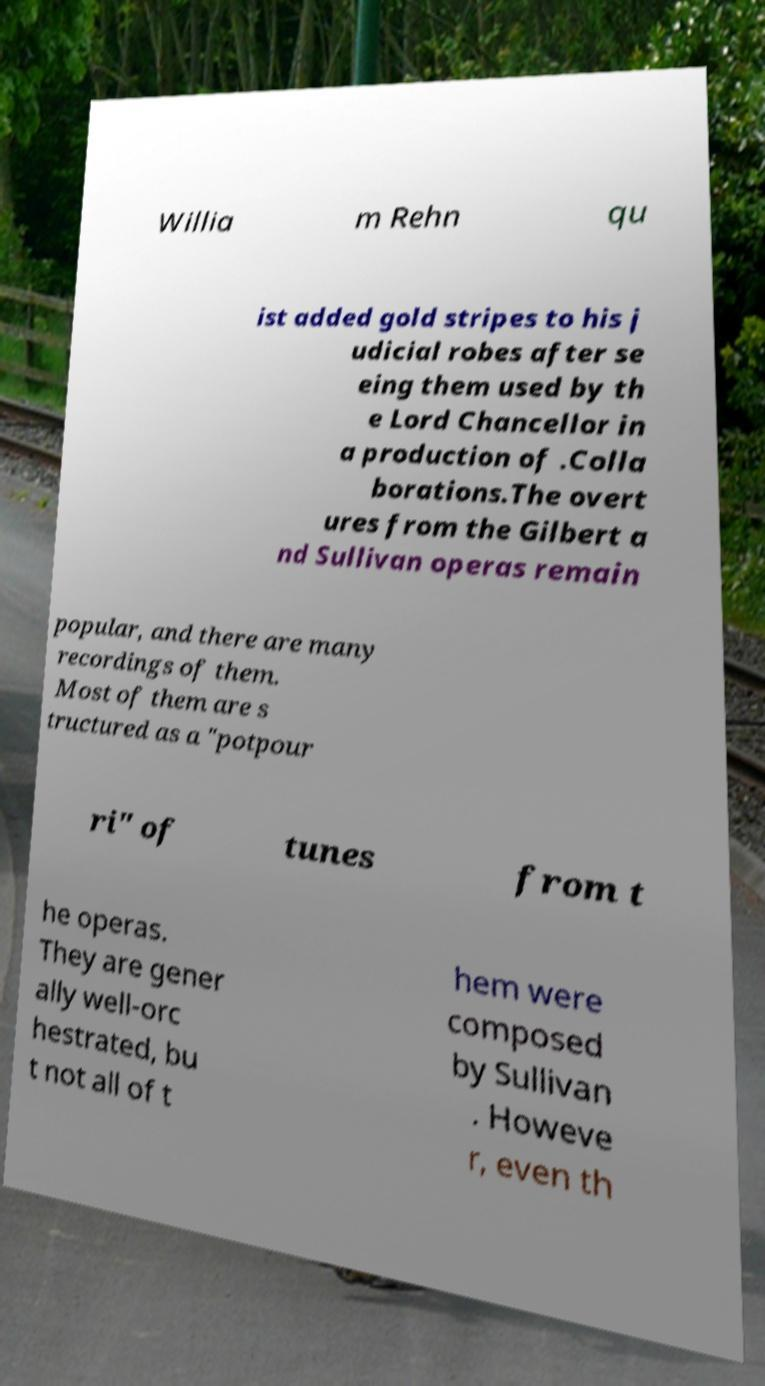There's text embedded in this image that I need extracted. Can you transcribe it verbatim? Willia m Rehn qu ist added gold stripes to his j udicial robes after se eing them used by th e Lord Chancellor in a production of .Colla borations.The overt ures from the Gilbert a nd Sullivan operas remain popular, and there are many recordings of them. Most of them are s tructured as a "potpour ri" of tunes from t he operas. They are gener ally well-orc hestrated, bu t not all of t hem were composed by Sullivan . Howeve r, even th 